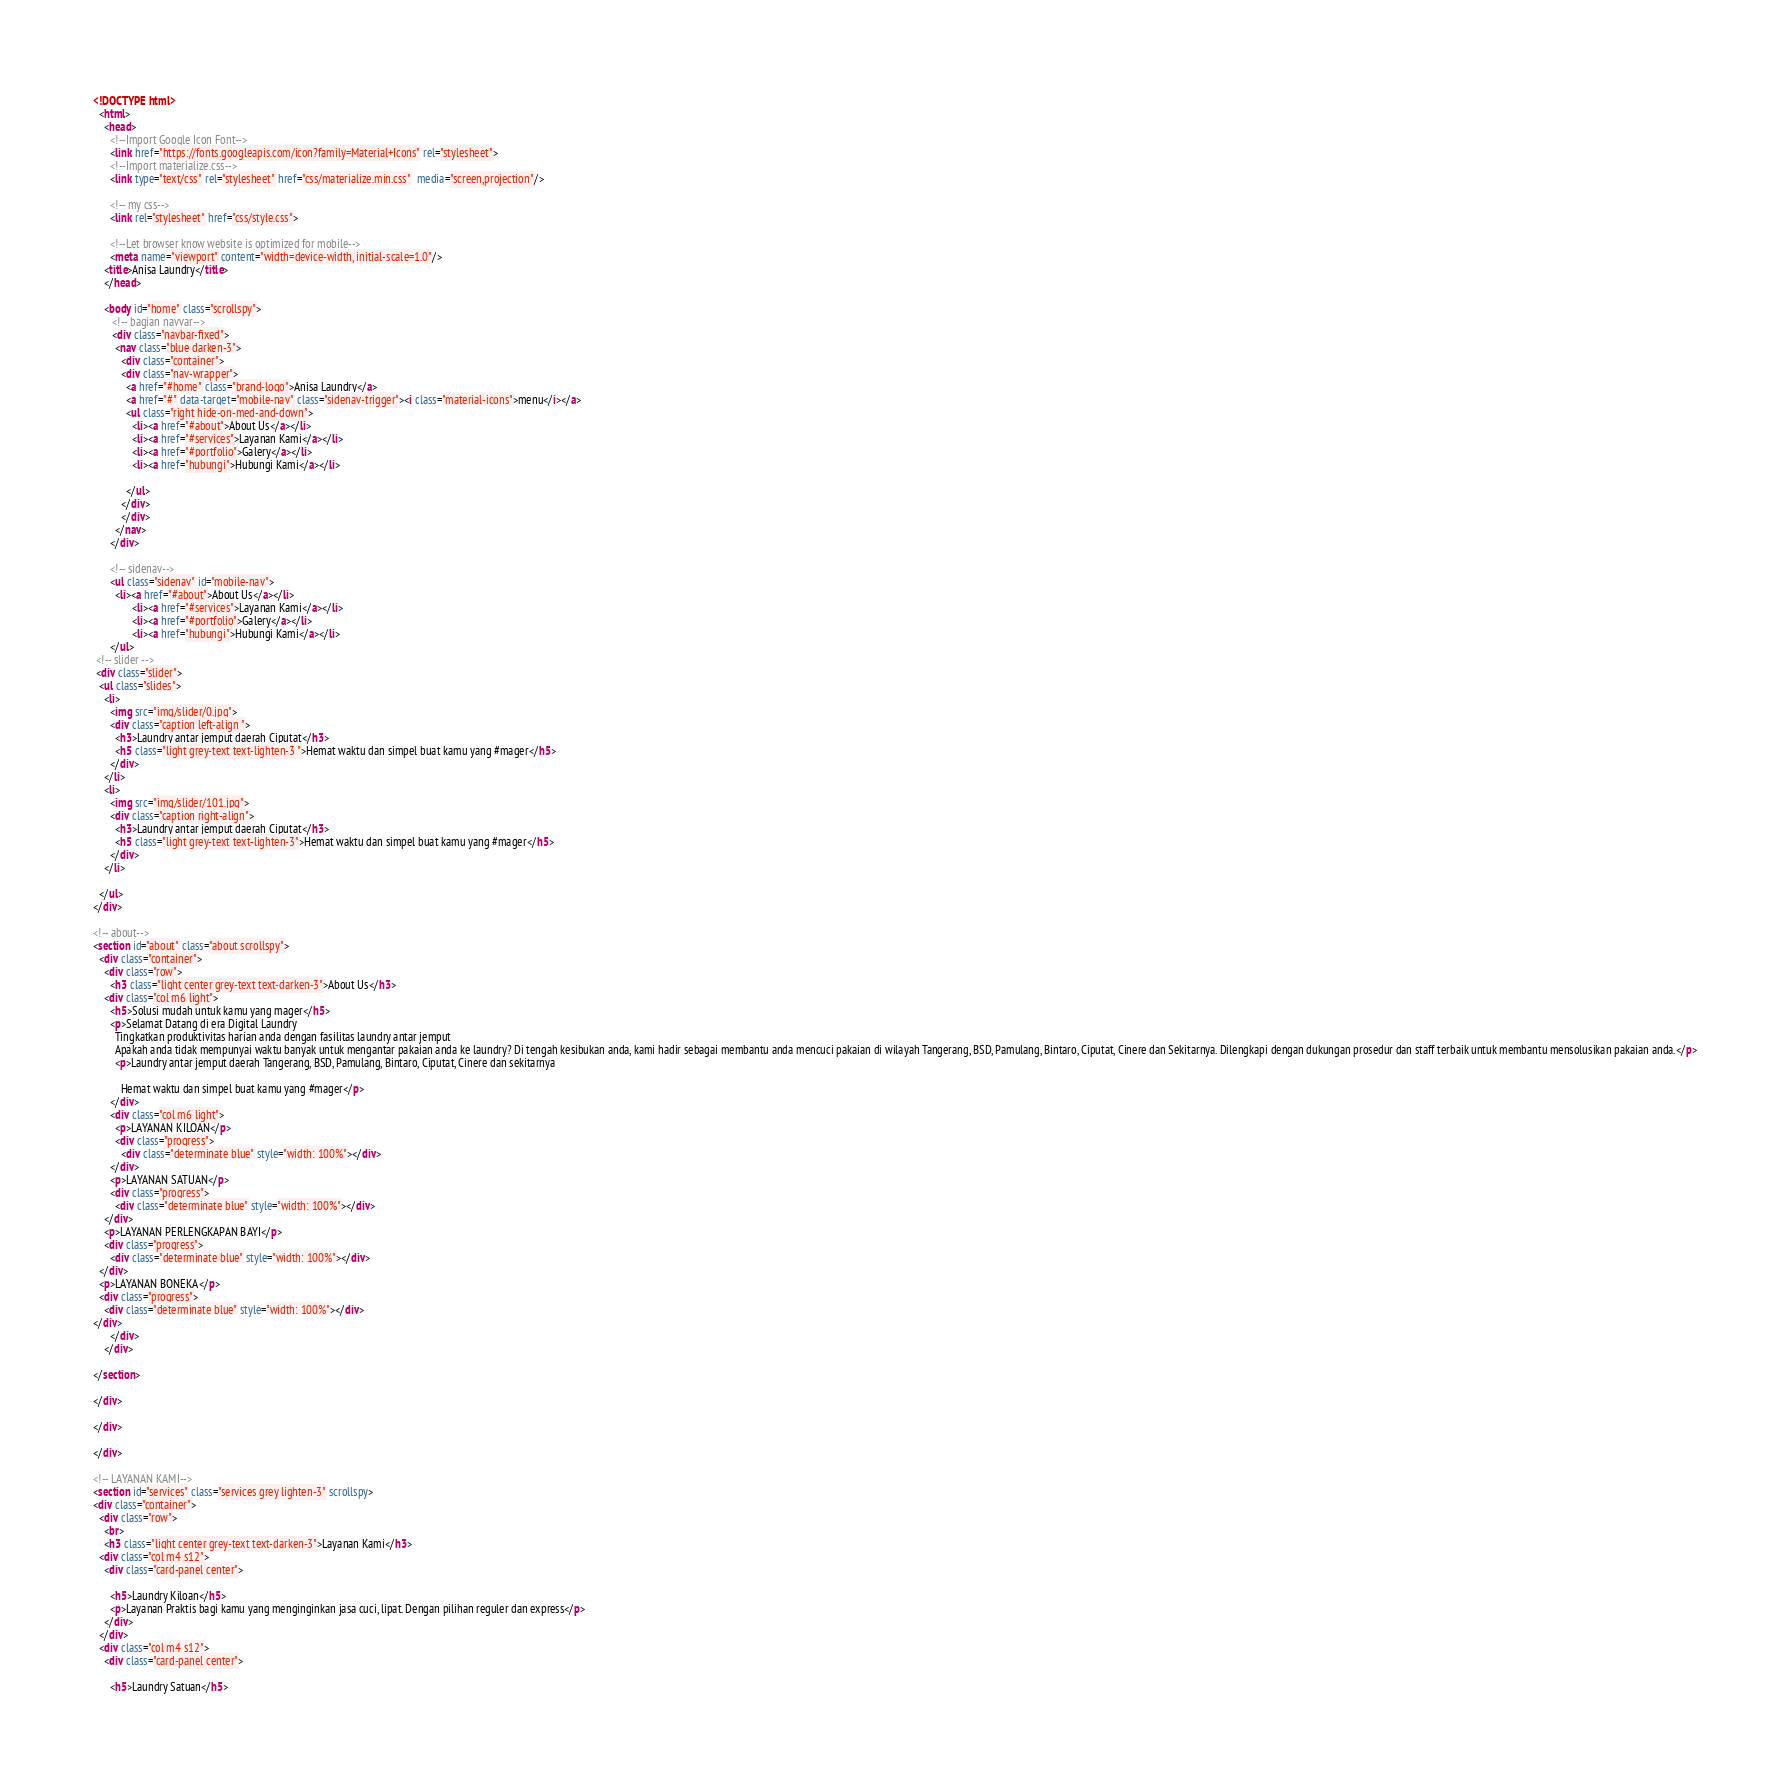<code> <loc_0><loc_0><loc_500><loc_500><_HTML_><!DOCTYPE html>
  <html>
    <head>
      <!--Import Google Icon Font-->
      <link href="https://fonts.googleapis.com/icon?family=Material+Icons" rel="stylesheet">
      <!--Import materialize.css-->
      <link type="text/css" rel="stylesheet" href="css/materialize.min.css"  media="screen,projection"/>

      <!-- my css-->
      <link rel="stylesheet" href="css/style.css">

      <!--Let browser know website is optimized for mobile-->
      <meta name="viewport" content="width=device-width, initial-scale=1.0"/>
    <title>Anisa Laundry</title>
    </head>

    <body id="home" class="scrollspy">
       <!-- bagian navvar-->
       <div class="navbar-fixed">
        <nav class="blue darken-3">
          <div class="container">
          <div class="nav-wrapper">
            <a href="#home" class="brand-logo">Anisa Laundry</a>
            <a href="#" data-target="mobile-nav" class="sidenav-trigger"><i class="material-icons">menu</i></a>
            <ul class="right hide-on-med-and-down">
              <li><a href="#about">About Us</a></li>
              <li><a href="#services">Layanan Kami</a></li>
              <li><a href="#portfolio">Galery</a></li>
              <li><a href="hubungi">Hubungi Kami</a></li>
              
            </ul>
          </div>
          </div>
        </nav>
      </div>

      <!-- sidenav-->
      <ul class="sidenav" id="mobile-nav">
        <li><a href="#about">About Us</a></li>
              <li><a href="#services">Layanan Kami</a></li>
              <li><a href="#portfolio">Galery</a></li>
              <li><a href="hubungi">Hubungi Kami</a></li>
      </ul>
 <!-- slider -->
 <div class="slider">
  <ul class="slides">
    <li>
      <img src="img/slider/0.jpg">
      <div class="caption left-align ">
        <h3>Laundry antar jemput daerah Ciputat</h3>
        <h5 class="light grey-text text-lighten-3 ">Hemat waktu dan simpel buat kamu yang #mager</h5>
      </div>
    </li>
    <li>
      <img src="img/slider/101.jpg">
      <div class="caption right-align">
        <h3>Laundry antar jemput daerah Ciputat</h3>
        <h5 class="light grey-text text-lighten-3">Hemat waktu dan simpel buat kamu yang #mager</h5>
      </div>
    </li>
    
  </ul>
</div>

<!-- about-->
<section id="about" class="about scrollspy">
  <div class="container"> 
    <div class="row">
      <h3 class="light center grey-text text-darken-3">About Us</h3>
    <div class="col m6 light">
      <h5>Solusi mudah untuk kamu yang mager</h5>
      <p>Selamat Datang di era Digital Laundry
        Tingkatkan produktivitas harian anda dengan fasilitas laundry antar jemput
        Apakah anda tidak mempunyai waktu banyak untuk mengantar pakaian anda ke laundry? Di tengah kesibukan anda, kami hadir sebagai membantu anda mencuci pakaian di wilayah Tangerang, BSD, Pamulang, Bintaro, Ciputat, Cinere dan Sekitarnya. Dilengkapi dengan dukungan prosedur dan staff terbaik untuk membantu mensolusikan pakaian anda.</p>
        <p>Laundry antar jemput daerah Tangerang, BSD, Pamulang, Bintaro, Ciputat, Cinere dan sekitarnya

          Hemat waktu dan simpel buat kamu yang #mager</p>
      </div>
      <div class="col m6 light">
        <p>LAYANAN KILOAN</p>
        <div class="progress">
          <div class="determinate blue" style="width: 100%"></div>
      </div>
      <p>LAYANAN SATUAN</p>
      <div class="progress">
        <div class="determinate blue" style="width: 100%"></div>
    </div>
    <p>LAYANAN PERLENGKAPAN BAYI</p>
    <div class="progress">
      <div class="determinate blue" style="width: 100%"></div>
  </div>
  <p>LAYANAN BONEKA</p>
  <div class="progress">
    <div class="determinate blue" style="width: 100%"></div>
</div>
      </div>
    </div>
  
</section>

</div>

</div>

</div>

<!-- LAYANAN KAMI-->
<section id="services" class="services grey lighten-3" scrollspy>
<div class="container">
  <div class="row">
    <br>
    <h3 class="light center grey-text text-darken-3">Layanan Kami</h3>
  <div class="col m4 s12">
    <div class="card-panel center">
     
      <h5>Laundry Kiloan</h5>
      <p>Layanan Praktis bagi kamu yang menginginkan jasa cuci, lipat. Dengan pilihan reguler dan express</p>
    </div>
  </div>
  <div class="col m4 s12">
    <div class="card-panel center">
     
      <h5>Laundry Satuan</h5></code> 